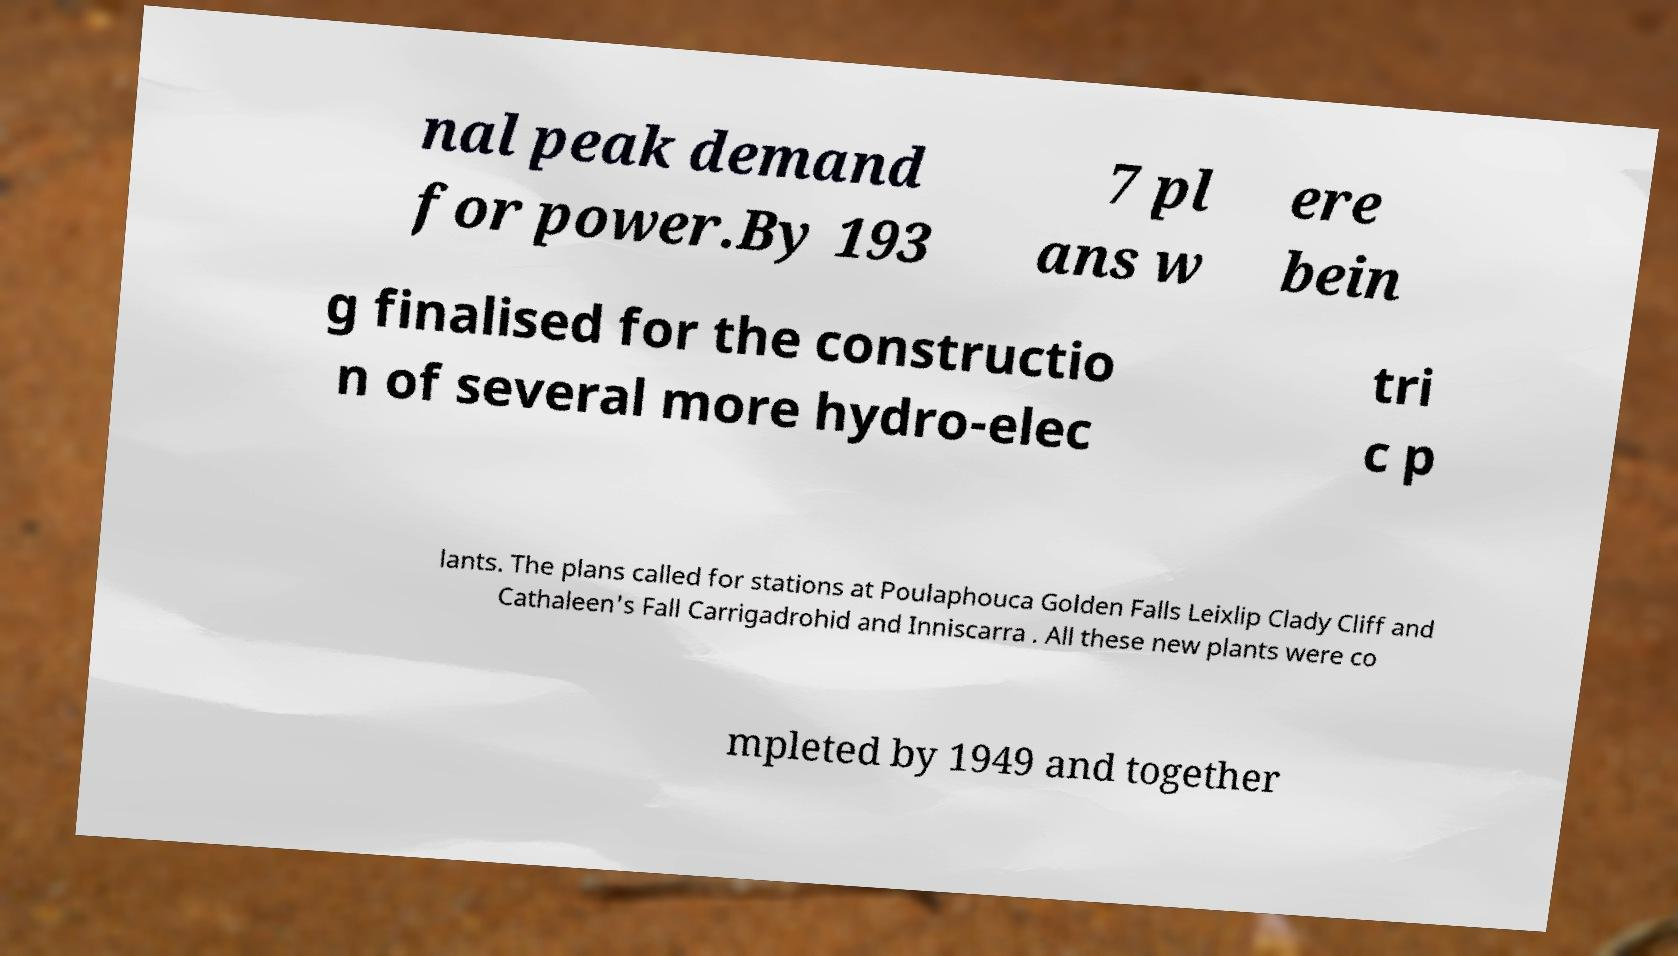Can you accurately transcribe the text from the provided image for me? nal peak demand for power.By 193 7 pl ans w ere bein g finalised for the constructio n of several more hydro-elec tri c p lants. The plans called for stations at Poulaphouca Golden Falls Leixlip Clady Cliff and Cathaleen's Fall Carrigadrohid and Inniscarra . All these new plants were co mpleted by 1949 and together 